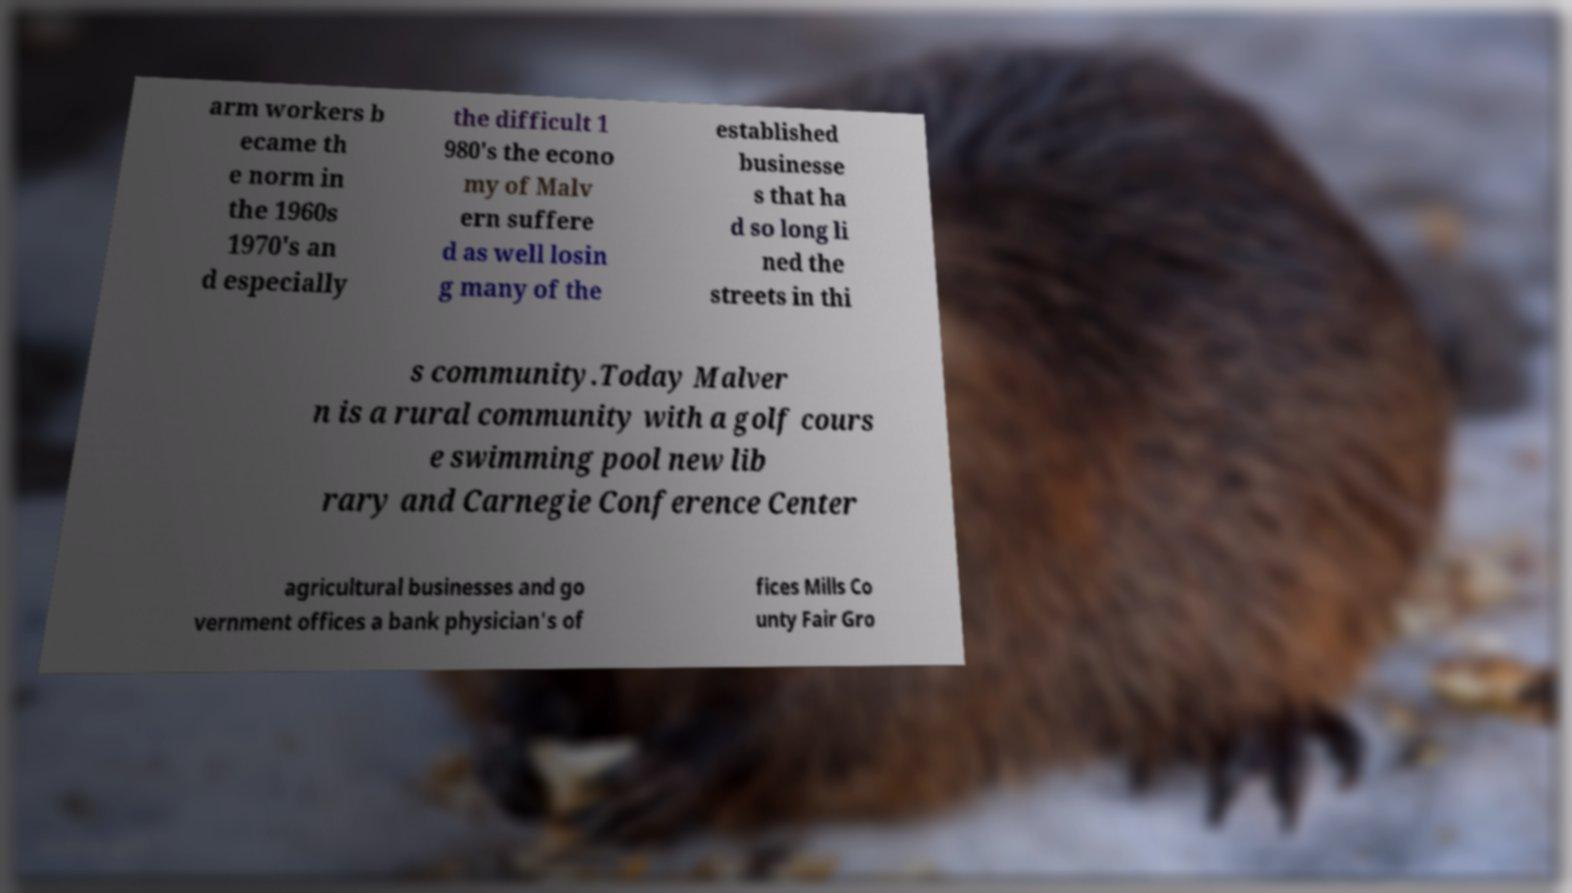I need the written content from this picture converted into text. Can you do that? arm workers b ecame th e norm in the 1960s 1970's an d especially the difficult 1 980's the econo my of Malv ern suffere d as well losin g many of the established businesse s that ha d so long li ned the streets in thi s community.Today Malver n is a rural community with a golf cours e swimming pool new lib rary and Carnegie Conference Center agricultural businesses and go vernment offices a bank physician's of fices Mills Co unty Fair Gro 